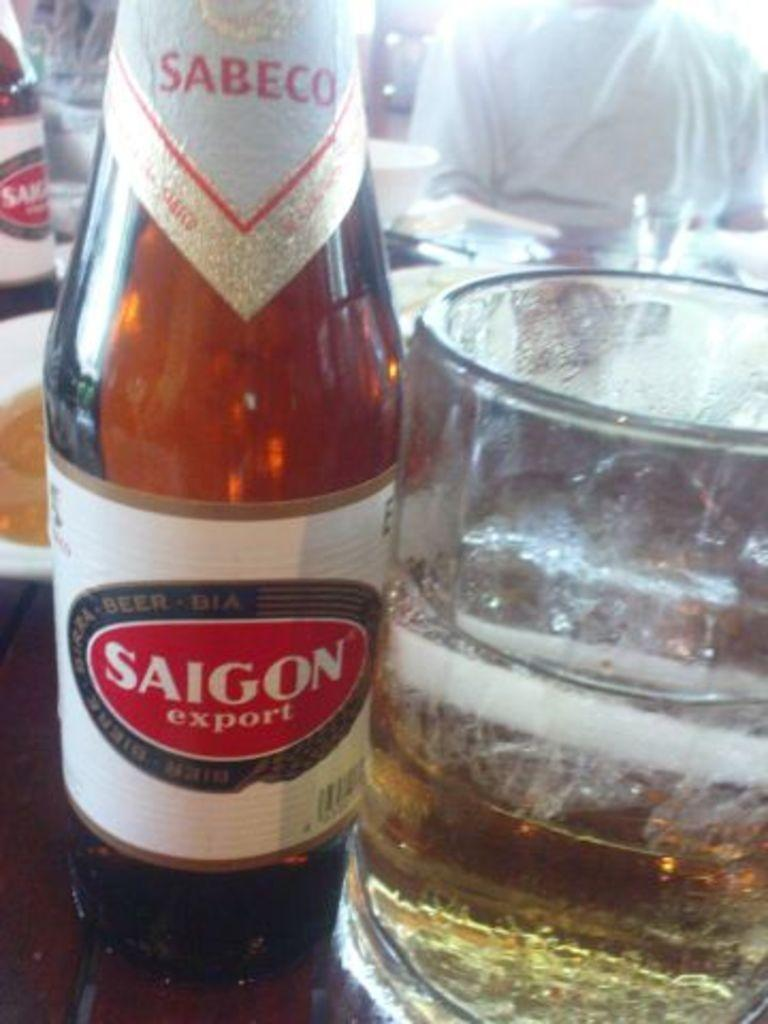<image>
Create a compact narrative representing the image presented. A bottle of Saigon export beer and a glass beside it. 